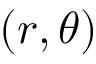Convert formula to latex. <formula><loc_0><loc_0><loc_500><loc_500>( r , \theta )</formula> 